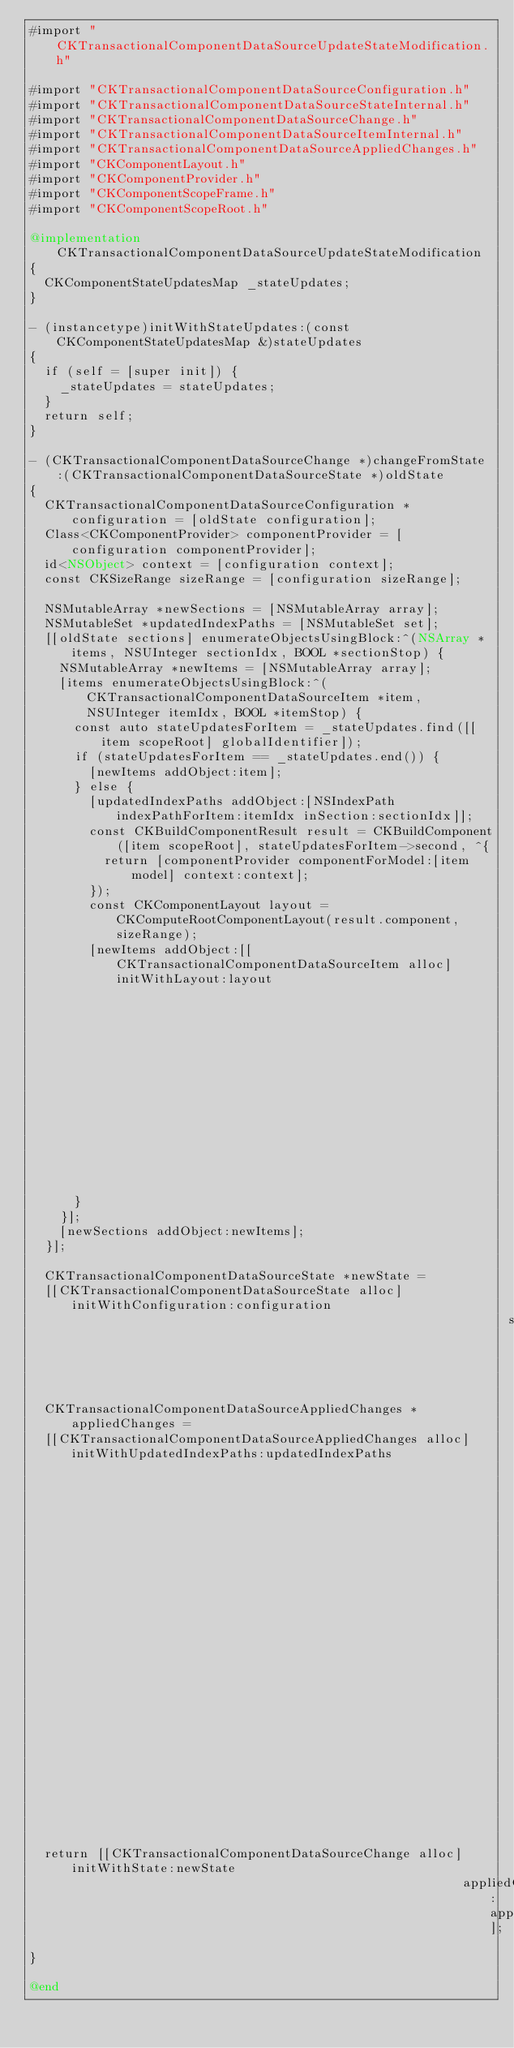Convert code to text. <code><loc_0><loc_0><loc_500><loc_500><_ObjectiveC_>#import "CKTransactionalComponentDataSourceUpdateStateModification.h"

#import "CKTransactionalComponentDataSourceConfiguration.h"
#import "CKTransactionalComponentDataSourceStateInternal.h"
#import "CKTransactionalComponentDataSourceChange.h"
#import "CKTransactionalComponentDataSourceItemInternal.h"
#import "CKTransactionalComponentDataSourceAppliedChanges.h"
#import "CKComponentLayout.h"
#import "CKComponentProvider.h"
#import "CKComponentScopeFrame.h"
#import "CKComponentScopeRoot.h"

@implementation CKTransactionalComponentDataSourceUpdateStateModification
{
  CKComponentStateUpdatesMap _stateUpdates;
}

- (instancetype)initWithStateUpdates:(const CKComponentStateUpdatesMap &)stateUpdates
{
  if (self = [super init]) {
    _stateUpdates = stateUpdates;
  }
  return self;
}

- (CKTransactionalComponentDataSourceChange *)changeFromState:(CKTransactionalComponentDataSourceState *)oldState
{
  CKTransactionalComponentDataSourceConfiguration *configuration = [oldState configuration];
  Class<CKComponentProvider> componentProvider = [configuration componentProvider];
  id<NSObject> context = [configuration context];
  const CKSizeRange sizeRange = [configuration sizeRange];

  NSMutableArray *newSections = [NSMutableArray array];
  NSMutableSet *updatedIndexPaths = [NSMutableSet set];
  [[oldState sections] enumerateObjectsUsingBlock:^(NSArray *items, NSUInteger sectionIdx, BOOL *sectionStop) {
    NSMutableArray *newItems = [NSMutableArray array];
    [items enumerateObjectsUsingBlock:^(CKTransactionalComponentDataSourceItem *item, NSUInteger itemIdx, BOOL *itemStop) {
      const auto stateUpdatesForItem = _stateUpdates.find([[item scopeRoot] globalIdentifier]);
      if (stateUpdatesForItem == _stateUpdates.end()) {
        [newItems addObject:item];
      } else {
        [updatedIndexPaths addObject:[NSIndexPath indexPathForItem:itemIdx inSection:sectionIdx]];
        const CKBuildComponentResult result = CKBuildComponent([item scopeRoot], stateUpdatesForItem->second, ^{
          return [componentProvider componentForModel:[item model] context:context];
        });
        const CKComponentLayout layout = CKComputeRootComponentLayout(result.component, sizeRange);
        [newItems addObject:[[CKTransactionalComponentDataSourceItem alloc] initWithLayout:layout
                                                                                     model:[item model]
                                                                                 scopeRoot:result.scopeRoot]];
      }
    }];
    [newSections addObject:newItems];
  }];

  CKTransactionalComponentDataSourceState *newState =
  [[CKTransactionalComponentDataSourceState alloc] initWithConfiguration:configuration
                                                                sections:newSections];

  CKTransactionalComponentDataSourceAppliedChanges *appliedChanges =
  [[CKTransactionalComponentDataSourceAppliedChanges alloc] initWithUpdatedIndexPaths:updatedIndexPaths
                                                                    removedIndexPaths:nil
                                                                      removedSections:nil
                                                                      movedIndexPaths:nil
                                                                     insertedSections:nil
                                                                   insertedIndexPaths:nil
                                                                             userInfo:nil];

  return [[CKTransactionalComponentDataSourceChange alloc] initWithState:newState
                                                          appliedChanges:appliedChanges];
}

@end
</code> 